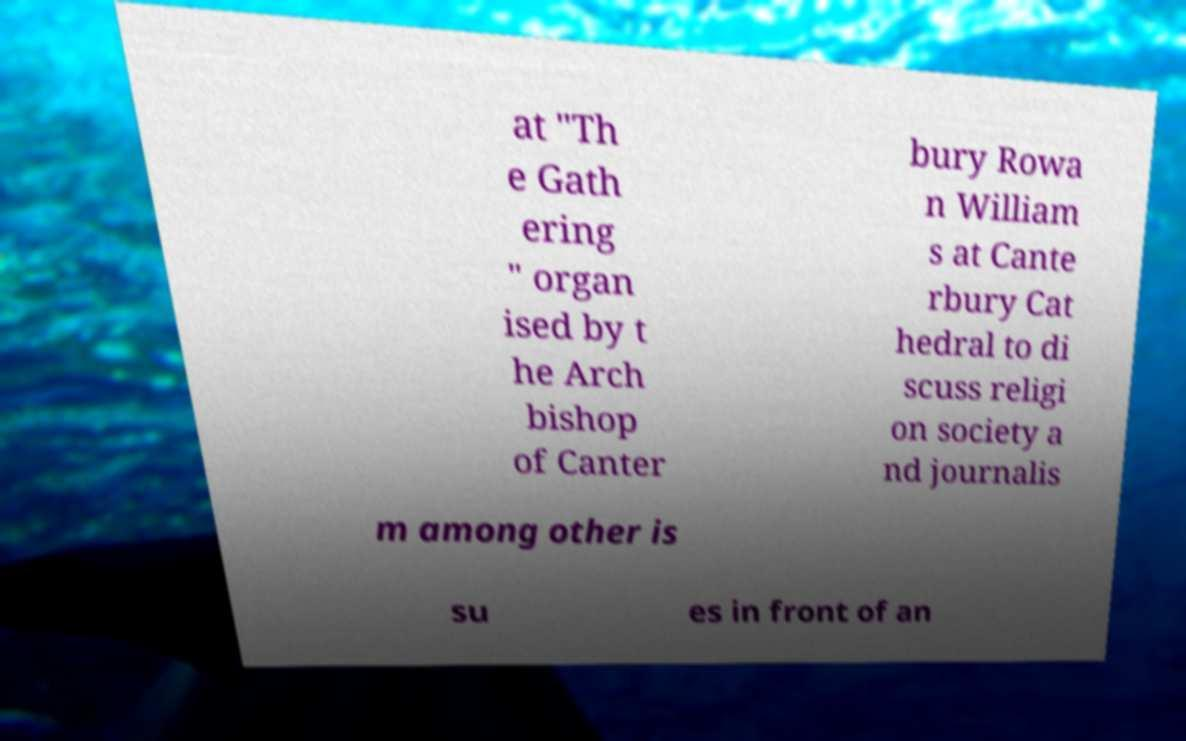Could you extract and type out the text from this image? at "Th e Gath ering " organ ised by t he Arch bishop of Canter bury Rowa n William s at Cante rbury Cat hedral to di scuss religi on society a nd journalis m among other is su es in front of an 